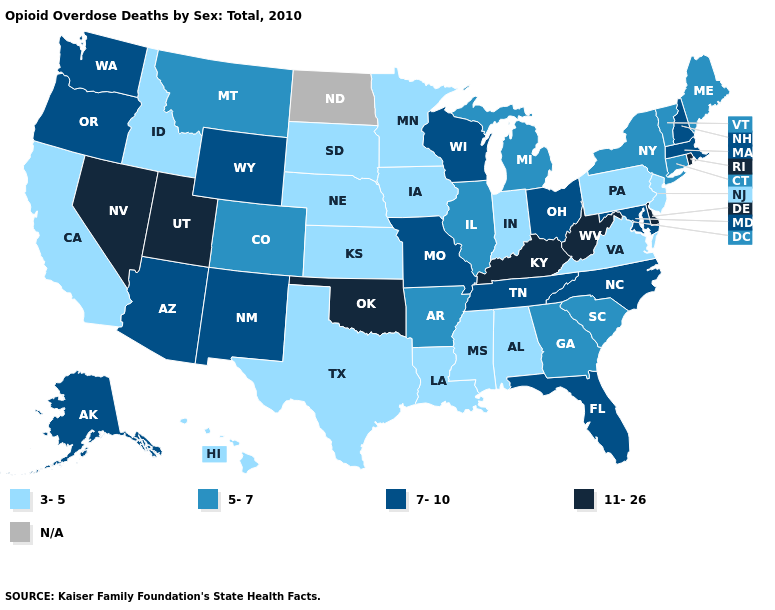What is the value of Ohio?
Short answer required. 7-10. Does the map have missing data?
Answer briefly. Yes. What is the highest value in the South ?
Short answer required. 11-26. Is the legend a continuous bar?
Quick response, please. No. What is the value of Nebraska?
Concise answer only. 3-5. Name the states that have a value in the range 5-7?
Concise answer only. Arkansas, Colorado, Connecticut, Georgia, Illinois, Maine, Michigan, Montana, New York, South Carolina, Vermont. Among the states that border North Dakota , does Montana have the highest value?
Quick response, please. Yes. Does the map have missing data?
Give a very brief answer. Yes. What is the value of Pennsylvania?
Answer briefly. 3-5. Which states have the lowest value in the South?
Concise answer only. Alabama, Louisiana, Mississippi, Texas, Virginia. Name the states that have a value in the range 3-5?
Write a very short answer. Alabama, California, Hawaii, Idaho, Indiana, Iowa, Kansas, Louisiana, Minnesota, Mississippi, Nebraska, New Jersey, Pennsylvania, South Dakota, Texas, Virginia. Does the map have missing data?
Write a very short answer. Yes. What is the value of Connecticut?
Keep it brief. 5-7. Does Rhode Island have the highest value in the Northeast?
Keep it brief. Yes. Among the states that border Oklahoma , does Texas have the highest value?
Concise answer only. No. 